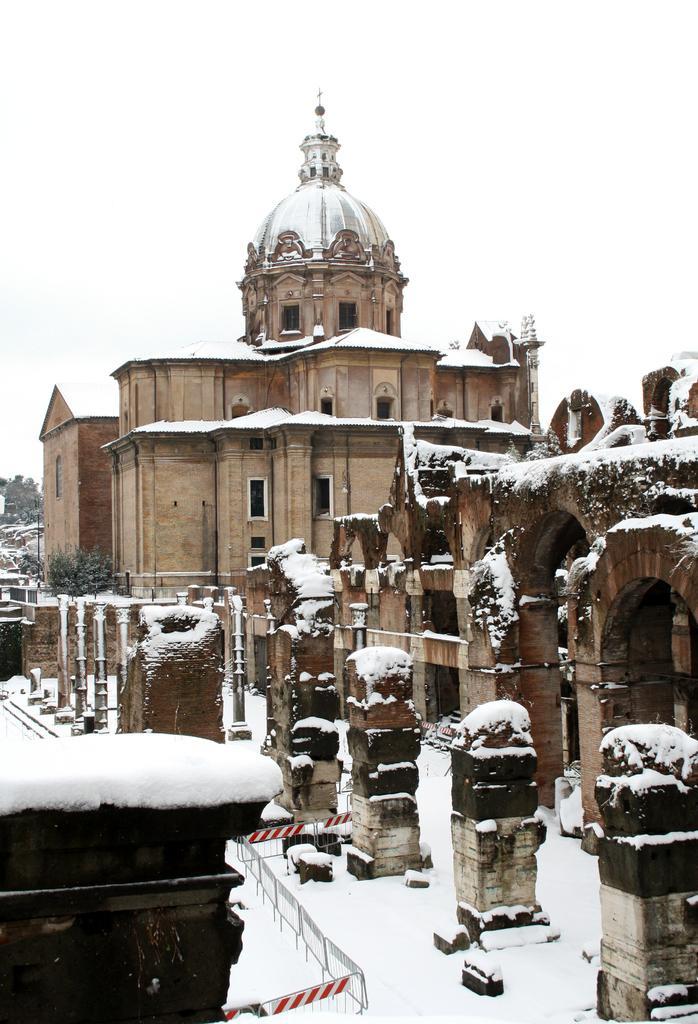How would you summarize this image in a sentence or two? In this picture we can see a fort, few trees and metal rods. 